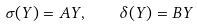<formula> <loc_0><loc_0><loc_500><loc_500>\sigma ( Y ) = A Y , \quad \delta ( Y ) = B Y</formula> 